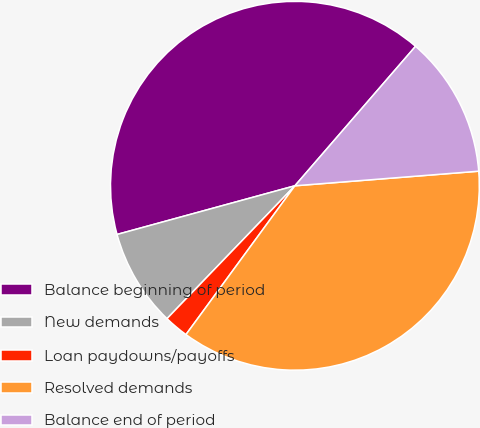Convert chart. <chart><loc_0><loc_0><loc_500><loc_500><pie_chart><fcel>Balance beginning of period<fcel>New demands<fcel>Loan paydowns/payoffs<fcel>Resolved demands<fcel>Balance end of period<nl><fcel>40.6%<fcel>8.55%<fcel>2.14%<fcel>36.32%<fcel>12.39%<nl></chart> 